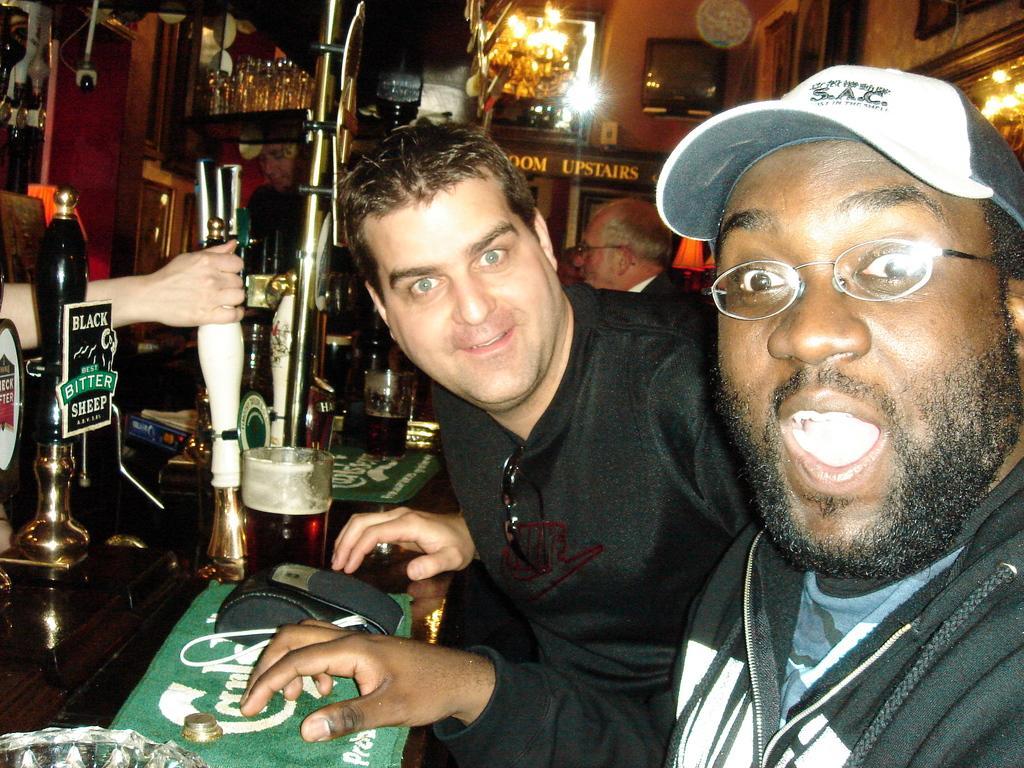Please provide a concise description of this image. On the right side of the image there is a man with black jacket and a cap on his head. Beside him there is a man with black t-shirt. In front of them there is a table with glasses and a few other items. And in the background there are lights and glasses. 